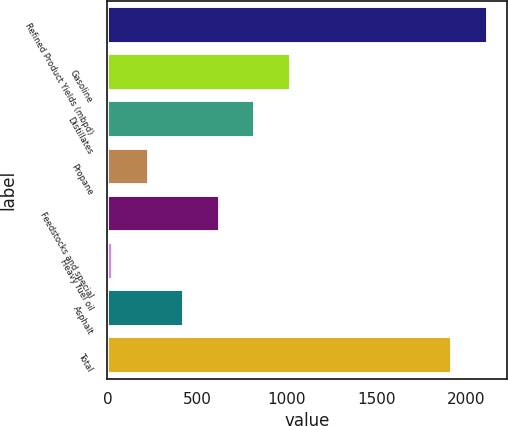Convert chart. <chart><loc_0><loc_0><loc_500><loc_500><bar_chart><fcel>Refined Product Yields (mbpd)<fcel>Gasoline<fcel>Distillates<fcel>Propane<fcel>Feedstocks and special<fcel>Heavy fuel oil<fcel>Asphalt<fcel>Total<nl><fcel>2117.4<fcel>1023<fcel>824.6<fcel>229.4<fcel>626.2<fcel>31<fcel>427.8<fcel>1919<nl></chart> 